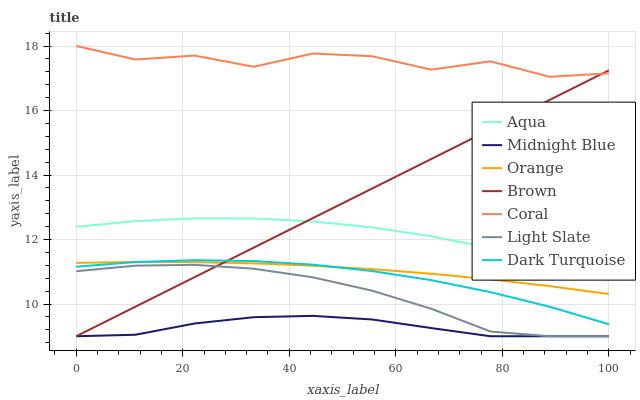Does Midnight Blue have the minimum area under the curve?
Answer yes or no. Yes. Does Light Slate have the minimum area under the curve?
Answer yes or no. No. Does Light Slate have the maximum area under the curve?
Answer yes or no. No. Is Coral the roughest?
Answer yes or no. Yes. Is Midnight Blue the smoothest?
Answer yes or no. No. Is Midnight Blue the roughest?
Answer yes or no. No. Does Dark Turquoise have the lowest value?
Answer yes or no. No. Does Light Slate have the highest value?
Answer yes or no. No. Is Midnight Blue less than Orange?
Answer yes or no. Yes. Is Coral greater than Light Slate?
Answer yes or no. Yes. Does Midnight Blue intersect Orange?
Answer yes or no. No. 